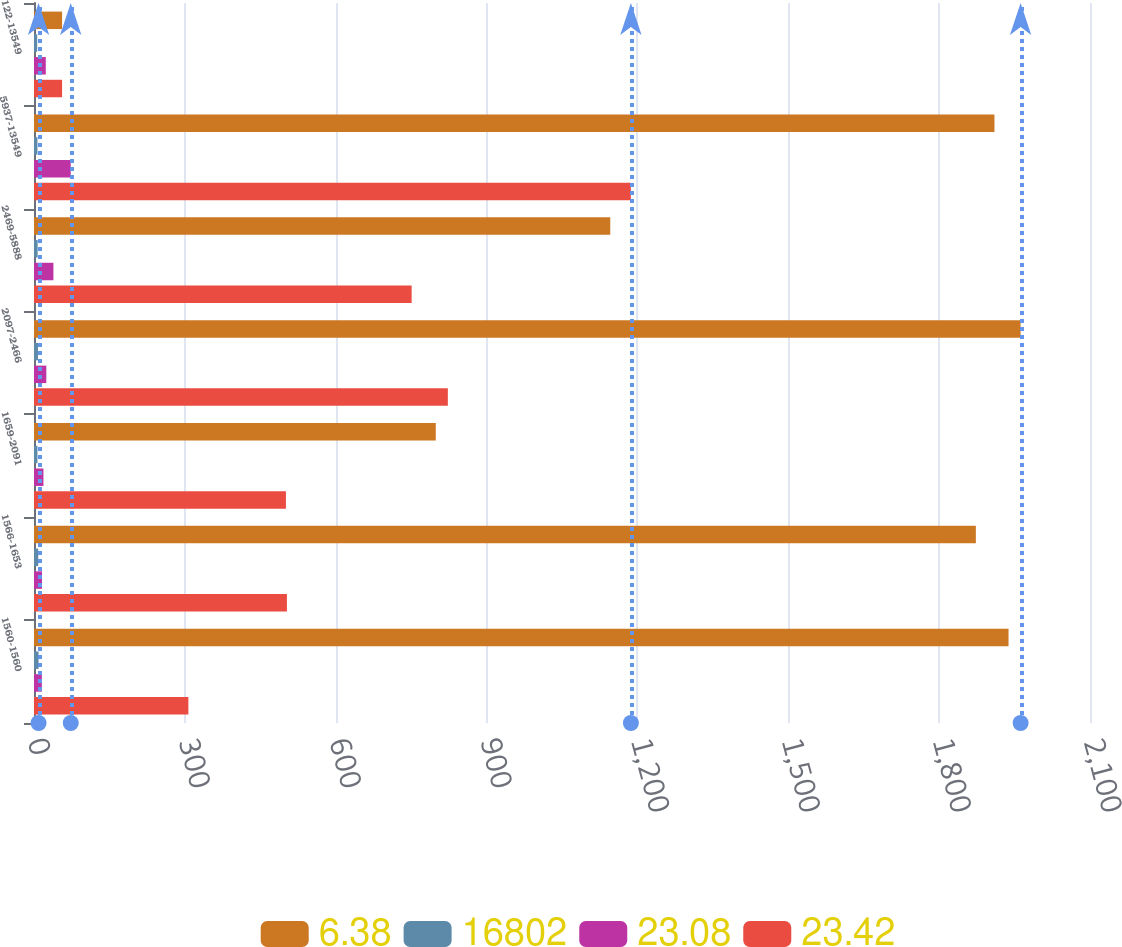Convert chart to OTSL. <chart><loc_0><loc_0><loc_500><loc_500><stacked_bar_chart><ecel><fcel>1560-1560<fcel>1566-1653<fcel>1659-2091<fcel>2097-2466<fcel>2469-5888<fcel>5937-13549<fcel>122-13549<nl><fcel>6.38<fcel>1938<fcel>1873<fcel>799<fcel>1962<fcel>1146<fcel>1910<fcel>55.84<nl><fcel>16802<fcel>9.05<fcel>8.45<fcel>6.89<fcel>7.89<fcel>7.24<fcel>6.89<fcel>6.38<nl><fcel>23.08<fcel>15.6<fcel>15.95<fcel>18.78<fcel>24.47<fcel>38.62<fcel>73.06<fcel>23.42<nl><fcel>23.42<fcel>307<fcel>503<fcel>501<fcel>823<fcel>751<fcel>1187<fcel>55.84<nl></chart> 